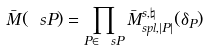<formula> <loc_0><loc_0><loc_500><loc_500>\bar { M } ( \ s P ) = \prod _ { P \in \ s P } \bar { M } ^ { s , \natural } _ { s p l , | P | } ( \delta _ { P } )</formula> 